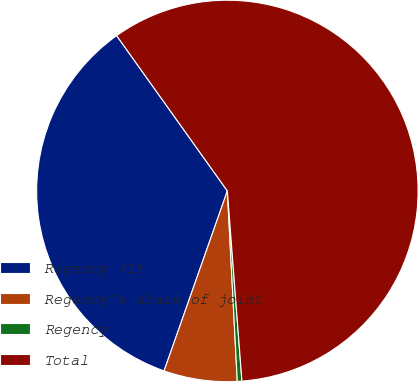Convert chart to OTSL. <chart><loc_0><loc_0><loc_500><loc_500><pie_chart><fcel>Regency (1)<fcel>Regency's share of joint<fcel>Regency<fcel>Total<nl><fcel>34.76%<fcel>6.21%<fcel>0.39%<fcel>58.64%<nl></chart> 